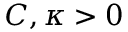<formula> <loc_0><loc_0><loc_500><loc_500>C , \kappa > 0</formula> 